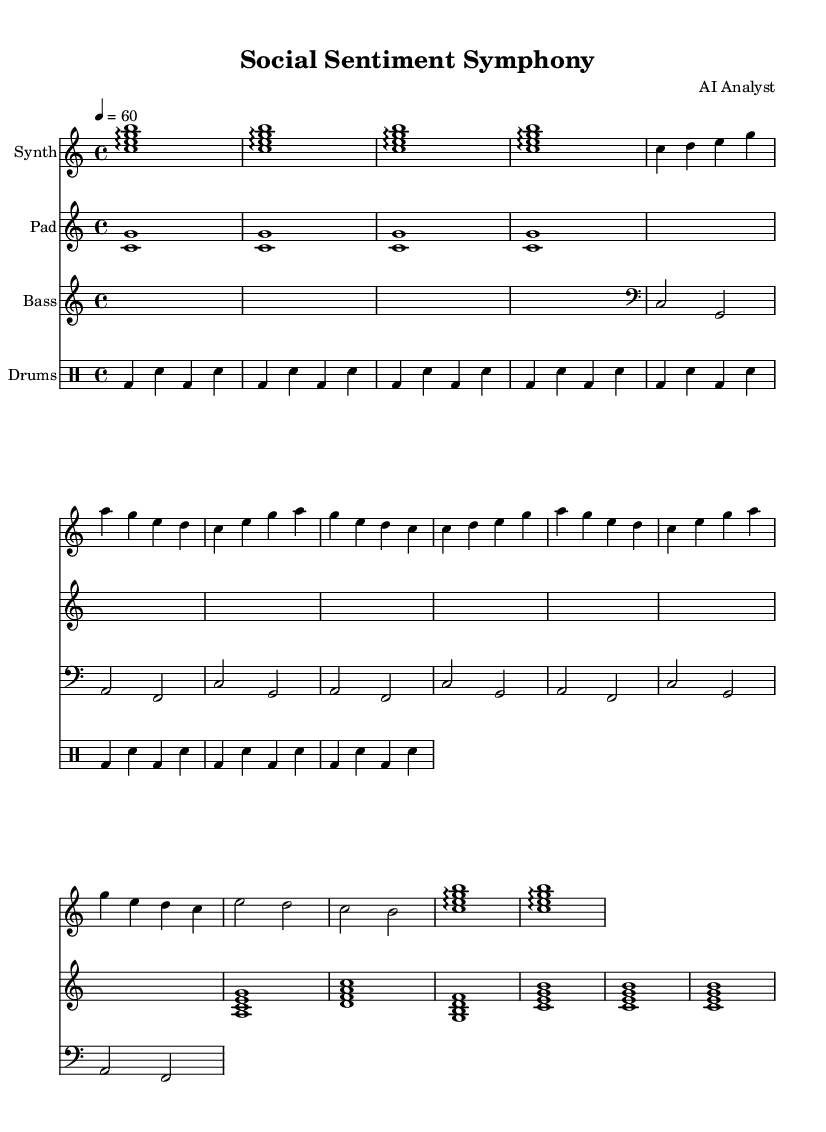What is the key signature of this music? The key signature is indicated at the beginning of the score, showing no sharps or flats, which corresponds to C major.
Answer: C major What is the time signature of this music? The time signature is found right after the key signature and is marked as 4/4, indicating four beats per measure.
Answer: 4/4 What is the tempo marking of this music? The tempo is indicated by the "tempo" text, which specifies a quarter note equals 60 beats per minute, indicating a moderate pace.
Answer: 60 How many measures are in the synth main theme? By counting the groupings of notes in the synth main theme, there are a total of 8 measures.
Answer: 8 Which instrument has a bridge section? The bridge section is noted with a unique set of measures, which here is displayed in the Pad staff, showing that this instrument includes a bridge.
Answer: Pad What is the rhythmic pattern of the drums in the main theme? The drum section contains repeated groups of bass drum and snare hits, specifically formatted in groups of two bass followed by two snares, indicating a structured rhythmic pattern.
Answer: bass drum and snare In which section does the synth use arpeggios? The synth intro and outro sections are highlighted with the use of arpeggios (noted with the arpeggio symbol), indicating a smooth flow in these parts.
Answer: Intro and Outro 